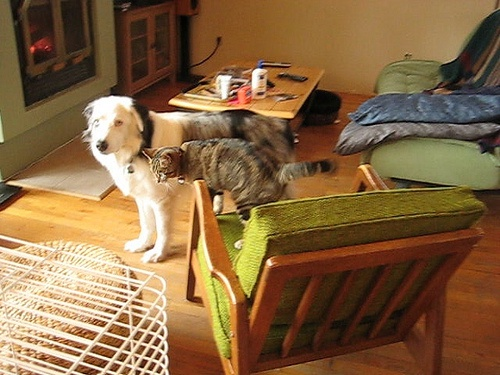Describe the objects in this image and their specific colors. I can see chair in olive, maroon, and black tones, couch in olive, gray, and black tones, dog in olive, ivory, tan, and maroon tones, cat in olive, maroon, gray, and tan tones, and dining table in olive, brown, tan, and black tones in this image. 